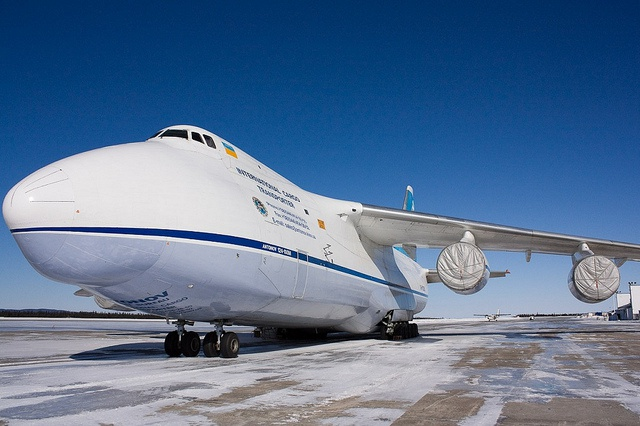Describe the objects in this image and their specific colors. I can see airplane in navy, lightgray, darkgray, and gray tones and airplane in navy, darkgray, lightgray, and gray tones in this image. 